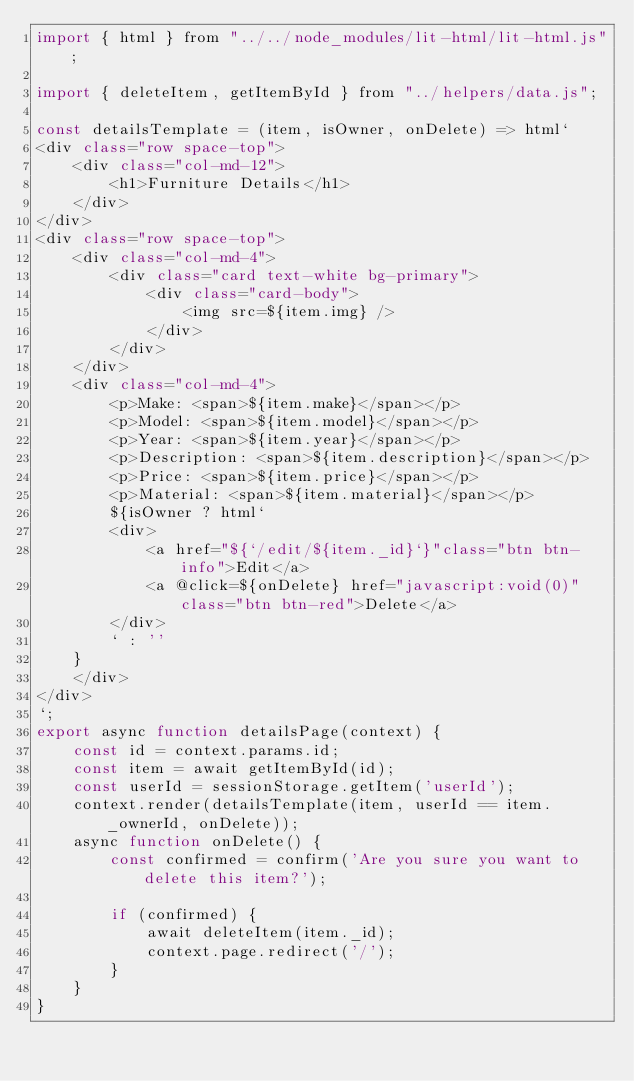Convert code to text. <code><loc_0><loc_0><loc_500><loc_500><_JavaScript_>import { html } from "../../node_modules/lit-html/lit-html.js";

import { deleteItem, getItemById } from "../helpers/data.js";

const detailsTemplate = (item, isOwner, onDelete) => html`
<div class="row space-top">
    <div class="col-md-12">
        <h1>Furniture Details</h1>
    </div>
</div>
<div class="row space-top">
    <div class="col-md-4">
        <div class="card text-white bg-primary">
            <div class="card-body">
                <img src=${item.img} />
            </div>
        </div>
    </div>
    <div class="col-md-4">
        <p>Make: <span>${item.make}</span></p>
        <p>Model: <span>${item.model}</span></p>
        <p>Year: <span>${item.year}</span></p>
        <p>Description: <span>${item.description}</span></p>
        <p>Price: <span>${item.price}</span></p>
        <p>Material: <span>${item.material}</span></p>
        ${isOwner ? html`
        <div>
            <a href="${`/edit/${item._id}`}"class="btn btn-info">Edit</a>
            <a @click=${onDelete} href="javascript:void(0)" class="btn btn-red">Delete</a>
        </div>
        ` : ''
    }
    </div>
</div>
`;
export async function detailsPage(context) {
    const id = context.params.id;
    const item = await getItemById(id);
    const userId = sessionStorage.getItem('userId');
    context.render(detailsTemplate(item, userId == item._ownerId, onDelete));
    async function onDelete() {
        const confirmed = confirm('Are you sure you want to delete this item?');

        if (confirmed) {
            await deleteItem(item._id);
            context.page.redirect('/');
        }
    }
}</code> 